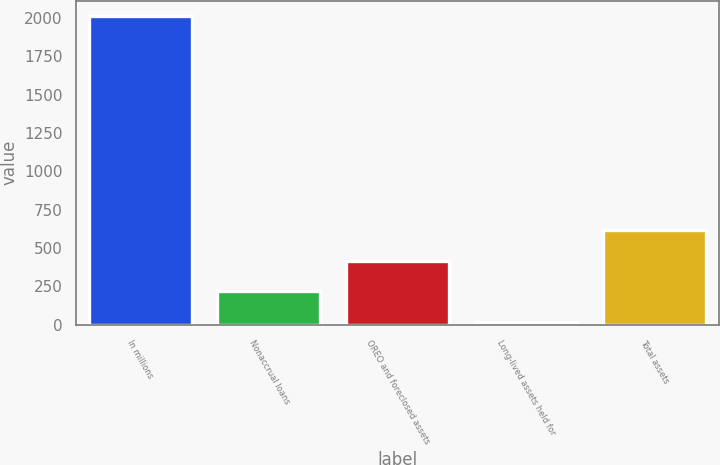Convert chart to OTSL. <chart><loc_0><loc_0><loc_500><loc_500><bar_chart><fcel>In millions<fcel>Nonaccrual loans<fcel>OREO and foreclosed assets<fcel>Long-lived assets held for<fcel>Total assets<nl><fcel>2012<fcel>219.2<fcel>418.4<fcel>20<fcel>617.6<nl></chart> 